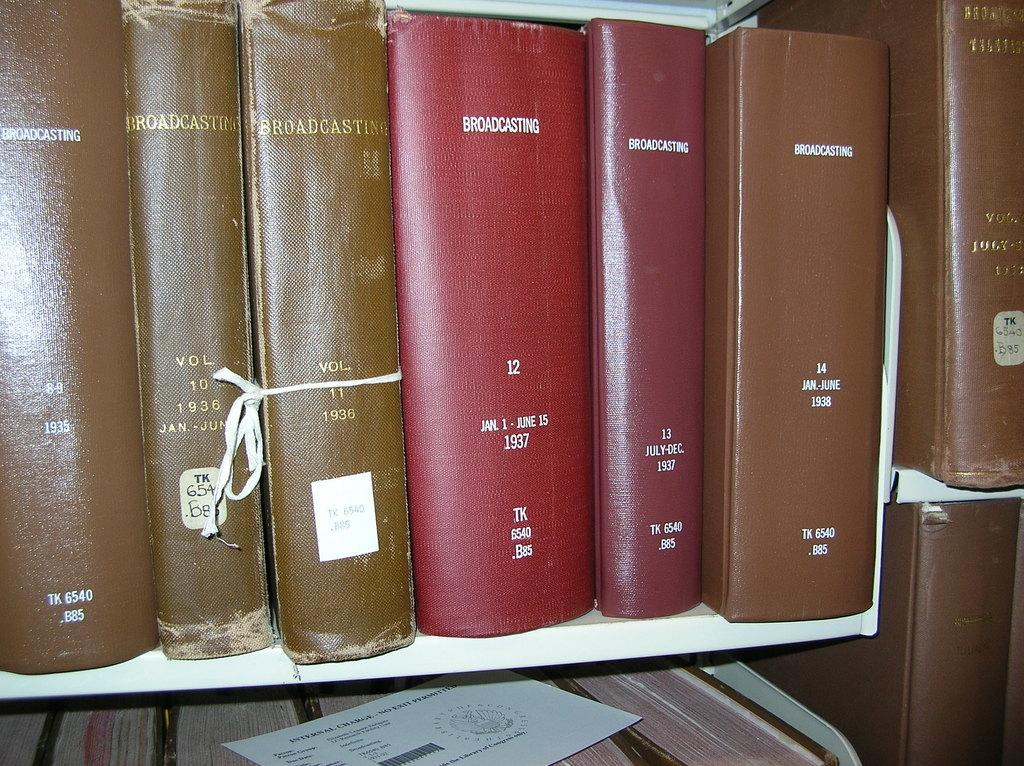<image>
Create a compact narrative representing the image presented. a row of books with one of them titled 'broadcasting' 